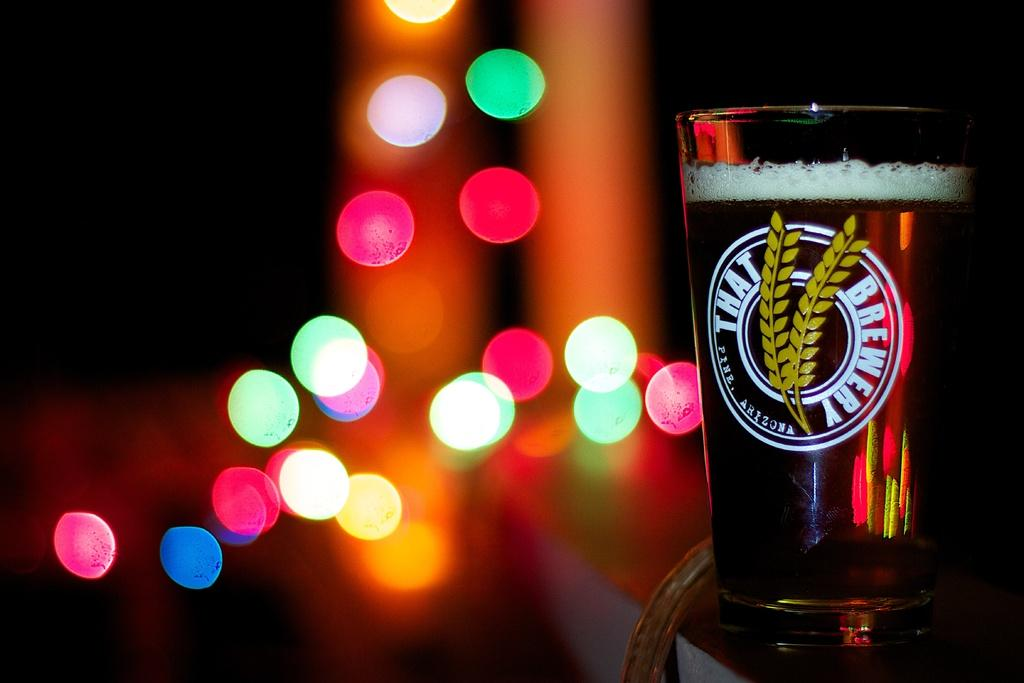<image>
Give a short and clear explanation of the subsequent image. The That Brewery of Pine, Arizona, glass of beer is full. 